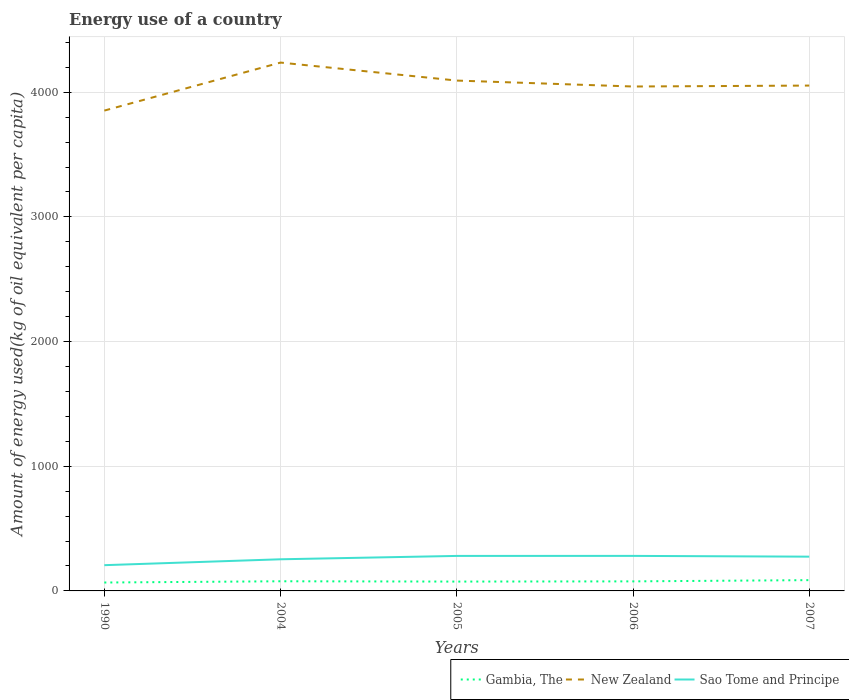Across all years, what is the maximum amount of energy used in in New Zealand?
Your response must be concise. 3852.64. What is the total amount of energy used in in Sao Tome and Principe in the graph?
Ensure brevity in your answer.  6.11. What is the difference between the highest and the second highest amount of energy used in in Sao Tome and Principe?
Provide a short and direct response. 74.48. What is the difference between the highest and the lowest amount of energy used in in New Zealand?
Keep it short and to the point. 2. How many lines are there?
Provide a short and direct response. 3. How many years are there in the graph?
Your answer should be compact. 5. What is the difference between two consecutive major ticks on the Y-axis?
Offer a very short reply. 1000. Does the graph contain grids?
Give a very brief answer. Yes. How many legend labels are there?
Give a very brief answer. 3. What is the title of the graph?
Make the answer very short. Energy use of a country. Does "Lao PDR" appear as one of the legend labels in the graph?
Your response must be concise. No. What is the label or title of the X-axis?
Keep it short and to the point. Years. What is the label or title of the Y-axis?
Ensure brevity in your answer.  Amount of energy used(kg of oil equivalent per capita). What is the Amount of energy used(kg of oil equivalent per capita) of Gambia, The in 1990?
Make the answer very short. 67.4. What is the Amount of energy used(kg of oil equivalent per capita) of New Zealand in 1990?
Keep it short and to the point. 3852.64. What is the Amount of energy used(kg of oil equivalent per capita) of Sao Tome and Principe in 1990?
Give a very brief answer. 206.52. What is the Amount of energy used(kg of oil equivalent per capita) of Gambia, The in 2004?
Offer a very short reply. 77.43. What is the Amount of energy used(kg of oil equivalent per capita) of New Zealand in 2004?
Your response must be concise. 4237.77. What is the Amount of energy used(kg of oil equivalent per capita) of Sao Tome and Principe in 2004?
Provide a succinct answer. 253.79. What is the Amount of energy used(kg of oil equivalent per capita) of Gambia, The in 2005?
Provide a succinct answer. 74.97. What is the Amount of energy used(kg of oil equivalent per capita) of New Zealand in 2005?
Ensure brevity in your answer.  4093.46. What is the Amount of energy used(kg of oil equivalent per capita) in Sao Tome and Principe in 2005?
Your answer should be very brief. 280.78. What is the Amount of energy used(kg of oil equivalent per capita) in Gambia, The in 2006?
Your response must be concise. 76.63. What is the Amount of energy used(kg of oil equivalent per capita) of New Zealand in 2006?
Ensure brevity in your answer.  4045.76. What is the Amount of energy used(kg of oil equivalent per capita) of Sao Tome and Principe in 2006?
Give a very brief answer. 281. What is the Amount of energy used(kg of oil equivalent per capita) in Gambia, The in 2007?
Your response must be concise. 86.56. What is the Amount of energy used(kg of oil equivalent per capita) of New Zealand in 2007?
Provide a succinct answer. 4053.33. What is the Amount of energy used(kg of oil equivalent per capita) of Sao Tome and Principe in 2007?
Make the answer very short. 274.89. Across all years, what is the maximum Amount of energy used(kg of oil equivalent per capita) of Gambia, The?
Give a very brief answer. 86.56. Across all years, what is the maximum Amount of energy used(kg of oil equivalent per capita) in New Zealand?
Make the answer very short. 4237.77. Across all years, what is the maximum Amount of energy used(kg of oil equivalent per capita) in Sao Tome and Principe?
Your answer should be very brief. 281. Across all years, what is the minimum Amount of energy used(kg of oil equivalent per capita) of Gambia, The?
Make the answer very short. 67.4. Across all years, what is the minimum Amount of energy used(kg of oil equivalent per capita) in New Zealand?
Provide a short and direct response. 3852.64. Across all years, what is the minimum Amount of energy used(kg of oil equivalent per capita) in Sao Tome and Principe?
Give a very brief answer. 206.52. What is the total Amount of energy used(kg of oil equivalent per capita) in Gambia, The in the graph?
Offer a terse response. 383. What is the total Amount of energy used(kg of oil equivalent per capita) in New Zealand in the graph?
Provide a succinct answer. 2.03e+04. What is the total Amount of energy used(kg of oil equivalent per capita) in Sao Tome and Principe in the graph?
Your answer should be very brief. 1296.98. What is the difference between the Amount of energy used(kg of oil equivalent per capita) in Gambia, The in 1990 and that in 2004?
Offer a very short reply. -10.04. What is the difference between the Amount of energy used(kg of oil equivalent per capita) of New Zealand in 1990 and that in 2004?
Your response must be concise. -385.14. What is the difference between the Amount of energy used(kg of oil equivalent per capita) of Sao Tome and Principe in 1990 and that in 2004?
Your answer should be very brief. -47.27. What is the difference between the Amount of energy used(kg of oil equivalent per capita) in Gambia, The in 1990 and that in 2005?
Offer a very short reply. -7.57. What is the difference between the Amount of energy used(kg of oil equivalent per capita) in New Zealand in 1990 and that in 2005?
Your answer should be very brief. -240.82. What is the difference between the Amount of energy used(kg of oil equivalent per capita) of Sao Tome and Principe in 1990 and that in 2005?
Your answer should be very brief. -74.26. What is the difference between the Amount of energy used(kg of oil equivalent per capita) in Gambia, The in 1990 and that in 2006?
Your answer should be very brief. -9.23. What is the difference between the Amount of energy used(kg of oil equivalent per capita) in New Zealand in 1990 and that in 2006?
Offer a very short reply. -193.12. What is the difference between the Amount of energy used(kg of oil equivalent per capita) in Sao Tome and Principe in 1990 and that in 2006?
Offer a terse response. -74.48. What is the difference between the Amount of energy used(kg of oil equivalent per capita) of Gambia, The in 1990 and that in 2007?
Your response must be concise. -19.17. What is the difference between the Amount of energy used(kg of oil equivalent per capita) in New Zealand in 1990 and that in 2007?
Make the answer very short. -200.7. What is the difference between the Amount of energy used(kg of oil equivalent per capita) of Sao Tome and Principe in 1990 and that in 2007?
Your response must be concise. -68.37. What is the difference between the Amount of energy used(kg of oil equivalent per capita) in Gambia, The in 2004 and that in 2005?
Your answer should be very brief. 2.46. What is the difference between the Amount of energy used(kg of oil equivalent per capita) of New Zealand in 2004 and that in 2005?
Give a very brief answer. 144.32. What is the difference between the Amount of energy used(kg of oil equivalent per capita) of Sao Tome and Principe in 2004 and that in 2005?
Give a very brief answer. -26.99. What is the difference between the Amount of energy used(kg of oil equivalent per capita) in Gambia, The in 2004 and that in 2006?
Offer a very short reply. 0.81. What is the difference between the Amount of energy used(kg of oil equivalent per capita) of New Zealand in 2004 and that in 2006?
Offer a terse response. 192.02. What is the difference between the Amount of energy used(kg of oil equivalent per capita) in Sao Tome and Principe in 2004 and that in 2006?
Your answer should be compact. -27.21. What is the difference between the Amount of energy used(kg of oil equivalent per capita) of Gambia, The in 2004 and that in 2007?
Make the answer very short. -9.13. What is the difference between the Amount of energy used(kg of oil equivalent per capita) of New Zealand in 2004 and that in 2007?
Offer a terse response. 184.44. What is the difference between the Amount of energy used(kg of oil equivalent per capita) of Sao Tome and Principe in 2004 and that in 2007?
Provide a short and direct response. -21.1. What is the difference between the Amount of energy used(kg of oil equivalent per capita) of Gambia, The in 2005 and that in 2006?
Provide a short and direct response. -1.66. What is the difference between the Amount of energy used(kg of oil equivalent per capita) in New Zealand in 2005 and that in 2006?
Ensure brevity in your answer.  47.7. What is the difference between the Amount of energy used(kg of oil equivalent per capita) of Sao Tome and Principe in 2005 and that in 2006?
Your answer should be compact. -0.22. What is the difference between the Amount of energy used(kg of oil equivalent per capita) of Gambia, The in 2005 and that in 2007?
Keep it short and to the point. -11.59. What is the difference between the Amount of energy used(kg of oil equivalent per capita) of New Zealand in 2005 and that in 2007?
Your answer should be compact. 40.12. What is the difference between the Amount of energy used(kg of oil equivalent per capita) in Sao Tome and Principe in 2005 and that in 2007?
Provide a succinct answer. 5.89. What is the difference between the Amount of energy used(kg of oil equivalent per capita) of Gambia, The in 2006 and that in 2007?
Offer a very short reply. -9.94. What is the difference between the Amount of energy used(kg of oil equivalent per capita) in New Zealand in 2006 and that in 2007?
Your response must be concise. -7.58. What is the difference between the Amount of energy used(kg of oil equivalent per capita) of Sao Tome and Principe in 2006 and that in 2007?
Keep it short and to the point. 6.11. What is the difference between the Amount of energy used(kg of oil equivalent per capita) of Gambia, The in 1990 and the Amount of energy used(kg of oil equivalent per capita) of New Zealand in 2004?
Provide a succinct answer. -4170.37. What is the difference between the Amount of energy used(kg of oil equivalent per capita) in Gambia, The in 1990 and the Amount of energy used(kg of oil equivalent per capita) in Sao Tome and Principe in 2004?
Your answer should be compact. -186.39. What is the difference between the Amount of energy used(kg of oil equivalent per capita) of New Zealand in 1990 and the Amount of energy used(kg of oil equivalent per capita) of Sao Tome and Principe in 2004?
Offer a terse response. 3598.85. What is the difference between the Amount of energy used(kg of oil equivalent per capita) of Gambia, The in 1990 and the Amount of energy used(kg of oil equivalent per capita) of New Zealand in 2005?
Keep it short and to the point. -4026.06. What is the difference between the Amount of energy used(kg of oil equivalent per capita) of Gambia, The in 1990 and the Amount of energy used(kg of oil equivalent per capita) of Sao Tome and Principe in 2005?
Your answer should be compact. -213.38. What is the difference between the Amount of energy used(kg of oil equivalent per capita) in New Zealand in 1990 and the Amount of energy used(kg of oil equivalent per capita) in Sao Tome and Principe in 2005?
Provide a succinct answer. 3571.86. What is the difference between the Amount of energy used(kg of oil equivalent per capita) of Gambia, The in 1990 and the Amount of energy used(kg of oil equivalent per capita) of New Zealand in 2006?
Give a very brief answer. -3978.36. What is the difference between the Amount of energy used(kg of oil equivalent per capita) of Gambia, The in 1990 and the Amount of energy used(kg of oil equivalent per capita) of Sao Tome and Principe in 2006?
Keep it short and to the point. -213.6. What is the difference between the Amount of energy used(kg of oil equivalent per capita) in New Zealand in 1990 and the Amount of energy used(kg of oil equivalent per capita) in Sao Tome and Principe in 2006?
Your answer should be compact. 3571.64. What is the difference between the Amount of energy used(kg of oil equivalent per capita) in Gambia, The in 1990 and the Amount of energy used(kg of oil equivalent per capita) in New Zealand in 2007?
Give a very brief answer. -3985.94. What is the difference between the Amount of energy used(kg of oil equivalent per capita) of Gambia, The in 1990 and the Amount of energy used(kg of oil equivalent per capita) of Sao Tome and Principe in 2007?
Provide a short and direct response. -207.49. What is the difference between the Amount of energy used(kg of oil equivalent per capita) of New Zealand in 1990 and the Amount of energy used(kg of oil equivalent per capita) of Sao Tome and Principe in 2007?
Your answer should be very brief. 3577.75. What is the difference between the Amount of energy used(kg of oil equivalent per capita) in Gambia, The in 2004 and the Amount of energy used(kg of oil equivalent per capita) in New Zealand in 2005?
Provide a succinct answer. -4016.02. What is the difference between the Amount of energy used(kg of oil equivalent per capita) in Gambia, The in 2004 and the Amount of energy used(kg of oil equivalent per capita) in Sao Tome and Principe in 2005?
Provide a short and direct response. -203.34. What is the difference between the Amount of energy used(kg of oil equivalent per capita) of New Zealand in 2004 and the Amount of energy used(kg of oil equivalent per capita) of Sao Tome and Principe in 2005?
Provide a short and direct response. 3957. What is the difference between the Amount of energy used(kg of oil equivalent per capita) of Gambia, The in 2004 and the Amount of energy used(kg of oil equivalent per capita) of New Zealand in 2006?
Give a very brief answer. -3968.32. What is the difference between the Amount of energy used(kg of oil equivalent per capita) in Gambia, The in 2004 and the Amount of energy used(kg of oil equivalent per capita) in Sao Tome and Principe in 2006?
Keep it short and to the point. -203.56. What is the difference between the Amount of energy used(kg of oil equivalent per capita) of New Zealand in 2004 and the Amount of energy used(kg of oil equivalent per capita) of Sao Tome and Principe in 2006?
Your response must be concise. 3956.77. What is the difference between the Amount of energy used(kg of oil equivalent per capita) in Gambia, The in 2004 and the Amount of energy used(kg of oil equivalent per capita) in New Zealand in 2007?
Offer a very short reply. -3975.9. What is the difference between the Amount of energy used(kg of oil equivalent per capita) in Gambia, The in 2004 and the Amount of energy used(kg of oil equivalent per capita) in Sao Tome and Principe in 2007?
Offer a terse response. -197.46. What is the difference between the Amount of energy used(kg of oil equivalent per capita) of New Zealand in 2004 and the Amount of energy used(kg of oil equivalent per capita) of Sao Tome and Principe in 2007?
Your answer should be compact. 3962.88. What is the difference between the Amount of energy used(kg of oil equivalent per capita) in Gambia, The in 2005 and the Amount of energy used(kg of oil equivalent per capita) in New Zealand in 2006?
Provide a succinct answer. -3970.78. What is the difference between the Amount of energy used(kg of oil equivalent per capita) of Gambia, The in 2005 and the Amount of energy used(kg of oil equivalent per capita) of Sao Tome and Principe in 2006?
Your response must be concise. -206.03. What is the difference between the Amount of energy used(kg of oil equivalent per capita) in New Zealand in 2005 and the Amount of energy used(kg of oil equivalent per capita) in Sao Tome and Principe in 2006?
Your answer should be very brief. 3812.46. What is the difference between the Amount of energy used(kg of oil equivalent per capita) of Gambia, The in 2005 and the Amount of energy used(kg of oil equivalent per capita) of New Zealand in 2007?
Offer a terse response. -3978.36. What is the difference between the Amount of energy used(kg of oil equivalent per capita) of Gambia, The in 2005 and the Amount of energy used(kg of oil equivalent per capita) of Sao Tome and Principe in 2007?
Keep it short and to the point. -199.92. What is the difference between the Amount of energy used(kg of oil equivalent per capita) in New Zealand in 2005 and the Amount of energy used(kg of oil equivalent per capita) in Sao Tome and Principe in 2007?
Offer a very short reply. 3818.57. What is the difference between the Amount of energy used(kg of oil equivalent per capita) of Gambia, The in 2006 and the Amount of energy used(kg of oil equivalent per capita) of New Zealand in 2007?
Your answer should be compact. -3976.71. What is the difference between the Amount of energy used(kg of oil equivalent per capita) of Gambia, The in 2006 and the Amount of energy used(kg of oil equivalent per capita) of Sao Tome and Principe in 2007?
Make the answer very short. -198.26. What is the difference between the Amount of energy used(kg of oil equivalent per capita) in New Zealand in 2006 and the Amount of energy used(kg of oil equivalent per capita) in Sao Tome and Principe in 2007?
Your answer should be very brief. 3770.87. What is the average Amount of energy used(kg of oil equivalent per capita) of Gambia, The per year?
Offer a terse response. 76.6. What is the average Amount of energy used(kg of oil equivalent per capita) in New Zealand per year?
Offer a terse response. 4056.59. What is the average Amount of energy used(kg of oil equivalent per capita) of Sao Tome and Principe per year?
Give a very brief answer. 259.39. In the year 1990, what is the difference between the Amount of energy used(kg of oil equivalent per capita) in Gambia, The and Amount of energy used(kg of oil equivalent per capita) in New Zealand?
Offer a very short reply. -3785.24. In the year 1990, what is the difference between the Amount of energy used(kg of oil equivalent per capita) of Gambia, The and Amount of energy used(kg of oil equivalent per capita) of Sao Tome and Principe?
Offer a very short reply. -139.12. In the year 1990, what is the difference between the Amount of energy used(kg of oil equivalent per capita) of New Zealand and Amount of energy used(kg of oil equivalent per capita) of Sao Tome and Principe?
Provide a short and direct response. 3646.11. In the year 2004, what is the difference between the Amount of energy used(kg of oil equivalent per capita) in Gambia, The and Amount of energy used(kg of oil equivalent per capita) in New Zealand?
Your answer should be very brief. -4160.34. In the year 2004, what is the difference between the Amount of energy used(kg of oil equivalent per capita) in Gambia, The and Amount of energy used(kg of oil equivalent per capita) in Sao Tome and Principe?
Your answer should be very brief. -176.35. In the year 2004, what is the difference between the Amount of energy used(kg of oil equivalent per capita) of New Zealand and Amount of energy used(kg of oil equivalent per capita) of Sao Tome and Principe?
Provide a succinct answer. 3983.99. In the year 2005, what is the difference between the Amount of energy used(kg of oil equivalent per capita) of Gambia, The and Amount of energy used(kg of oil equivalent per capita) of New Zealand?
Provide a succinct answer. -4018.49. In the year 2005, what is the difference between the Amount of energy used(kg of oil equivalent per capita) in Gambia, The and Amount of energy used(kg of oil equivalent per capita) in Sao Tome and Principe?
Offer a very short reply. -205.81. In the year 2005, what is the difference between the Amount of energy used(kg of oil equivalent per capita) of New Zealand and Amount of energy used(kg of oil equivalent per capita) of Sao Tome and Principe?
Your response must be concise. 3812.68. In the year 2006, what is the difference between the Amount of energy used(kg of oil equivalent per capita) of Gambia, The and Amount of energy used(kg of oil equivalent per capita) of New Zealand?
Your answer should be very brief. -3969.13. In the year 2006, what is the difference between the Amount of energy used(kg of oil equivalent per capita) of Gambia, The and Amount of energy used(kg of oil equivalent per capita) of Sao Tome and Principe?
Provide a short and direct response. -204.37. In the year 2006, what is the difference between the Amount of energy used(kg of oil equivalent per capita) of New Zealand and Amount of energy used(kg of oil equivalent per capita) of Sao Tome and Principe?
Offer a terse response. 3764.76. In the year 2007, what is the difference between the Amount of energy used(kg of oil equivalent per capita) in Gambia, The and Amount of energy used(kg of oil equivalent per capita) in New Zealand?
Your response must be concise. -3966.77. In the year 2007, what is the difference between the Amount of energy used(kg of oil equivalent per capita) of Gambia, The and Amount of energy used(kg of oil equivalent per capita) of Sao Tome and Principe?
Ensure brevity in your answer.  -188.33. In the year 2007, what is the difference between the Amount of energy used(kg of oil equivalent per capita) in New Zealand and Amount of energy used(kg of oil equivalent per capita) in Sao Tome and Principe?
Your response must be concise. 3778.44. What is the ratio of the Amount of energy used(kg of oil equivalent per capita) in Gambia, The in 1990 to that in 2004?
Offer a very short reply. 0.87. What is the ratio of the Amount of energy used(kg of oil equivalent per capita) in Sao Tome and Principe in 1990 to that in 2004?
Your answer should be very brief. 0.81. What is the ratio of the Amount of energy used(kg of oil equivalent per capita) in Gambia, The in 1990 to that in 2005?
Ensure brevity in your answer.  0.9. What is the ratio of the Amount of energy used(kg of oil equivalent per capita) of New Zealand in 1990 to that in 2005?
Provide a short and direct response. 0.94. What is the ratio of the Amount of energy used(kg of oil equivalent per capita) in Sao Tome and Principe in 1990 to that in 2005?
Offer a very short reply. 0.74. What is the ratio of the Amount of energy used(kg of oil equivalent per capita) of Gambia, The in 1990 to that in 2006?
Provide a short and direct response. 0.88. What is the ratio of the Amount of energy used(kg of oil equivalent per capita) in New Zealand in 1990 to that in 2006?
Offer a very short reply. 0.95. What is the ratio of the Amount of energy used(kg of oil equivalent per capita) of Sao Tome and Principe in 1990 to that in 2006?
Provide a succinct answer. 0.73. What is the ratio of the Amount of energy used(kg of oil equivalent per capita) of Gambia, The in 1990 to that in 2007?
Provide a short and direct response. 0.78. What is the ratio of the Amount of energy used(kg of oil equivalent per capita) of New Zealand in 1990 to that in 2007?
Keep it short and to the point. 0.95. What is the ratio of the Amount of energy used(kg of oil equivalent per capita) of Sao Tome and Principe in 1990 to that in 2007?
Offer a terse response. 0.75. What is the ratio of the Amount of energy used(kg of oil equivalent per capita) in Gambia, The in 2004 to that in 2005?
Offer a terse response. 1.03. What is the ratio of the Amount of energy used(kg of oil equivalent per capita) in New Zealand in 2004 to that in 2005?
Provide a succinct answer. 1.04. What is the ratio of the Amount of energy used(kg of oil equivalent per capita) of Sao Tome and Principe in 2004 to that in 2005?
Your answer should be compact. 0.9. What is the ratio of the Amount of energy used(kg of oil equivalent per capita) of Gambia, The in 2004 to that in 2006?
Keep it short and to the point. 1.01. What is the ratio of the Amount of energy used(kg of oil equivalent per capita) of New Zealand in 2004 to that in 2006?
Your response must be concise. 1.05. What is the ratio of the Amount of energy used(kg of oil equivalent per capita) of Sao Tome and Principe in 2004 to that in 2006?
Provide a succinct answer. 0.9. What is the ratio of the Amount of energy used(kg of oil equivalent per capita) of Gambia, The in 2004 to that in 2007?
Make the answer very short. 0.89. What is the ratio of the Amount of energy used(kg of oil equivalent per capita) of New Zealand in 2004 to that in 2007?
Your answer should be compact. 1.05. What is the ratio of the Amount of energy used(kg of oil equivalent per capita) in Sao Tome and Principe in 2004 to that in 2007?
Provide a succinct answer. 0.92. What is the ratio of the Amount of energy used(kg of oil equivalent per capita) of Gambia, The in 2005 to that in 2006?
Give a very brief answer. 0.98. What is the ratio of the Amount of energy used(kg of oil equivalent per capita) in New Zealand in 2005 to that in 2006?
Provide a succinct answer. 1.01. What is the ratio of the Amount of energy used(kg of oil equivalent per capita) of Gambia, The in 2005 to that in 2007?
Your response must be concise. 0.87. What is the ratio of the Amount of energy used(kg of oil equivalent per capita) of New Zealand in 2005 to that in 2007?
Ensure brevity in your answer.  1.01. What is the ratio of the Amount of energy used(kg of oil equivalent per capita) of Sao Tome and Principe in 2005 to that in 2007?
Keep it short and to the point. 1.02. What is the ratio of the Amount of energy used(kg of oil equivalent per capita) of Gambia, The in 2006 to that in 2007?
Your response must be concise. 0.89. What is the ratio of the Amount of energy used(kg of oil equivalent per capita) in New Zealand in 2006 to that in 2007?
Provide a short and direct response. 1. What is the ratio of the Amount of energy used(kg of oil equivalent per capita) in Sao Tome and Principe in 2006 to that in 2007?
Make the answer very short. 1.02. What is the difference between the highest and the second highest Amount of energy used(kg of oil equivalent per capita) in Gambia, The?
Keep it short and to the point. 9.13. What is the difference between the highest and the second highest Amount of energy used(kg of oil equivalent per capita) of New Zealand?
Offer a very short reply. 144.32. What is the difference between the highest and the second highest Amount of energy used(kg of oil equivalent per capita) in Sao Tome and Principe?
Your response must be concise. 0.22. What is the difference between the highest and the lowest Amount of energy used(kg of oil equivalent per capita) in Gambia, The?
Give a very brief answer. 19.17. What is the difference between the highest and the lowest Amount of energy used(kg of oil equivalent per capita) in New Zealand?
Your response must be concise. 385.14. What is the difference between the highest and the lowest Amount of energy used(kg of oil equivalent per capita) in Sao Tome and Principe?
Your answer should be compact. 74.48. 